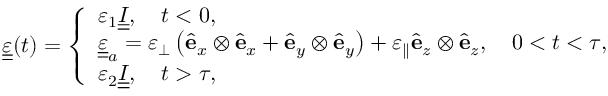<formula> <loc_0><loc_0><loc_500><loc_500>\begin{array} { r } { \underline { { \underline { \varepsilon } } } ( t ) = \left \{ \begin{array} { l l } { \varepsilon _ { 1 } \underline { { \underline { I } } } , \quad t < 0 , } \\ { \underline { { \underline { \varepsilon } } } _ { a } = \varepsilon _ { \perp } \left ( { \hat { e } } _ { x } \otimes { \hat { e } } _ { x } + { \hat { e } } _ { y } \otimes { \hat { e } } _ { y } \right ) + \varepsilon _ { \| } { \hat { e } } _ { z } \otimes { \hat { e } } _ { z } , \quad 0 < t < \tau , } \\ { \varepsilon _ { 2 } \underline { { \underline { I } } } , \quad t > \tau , } \end{array} } \end{array}</formula> 